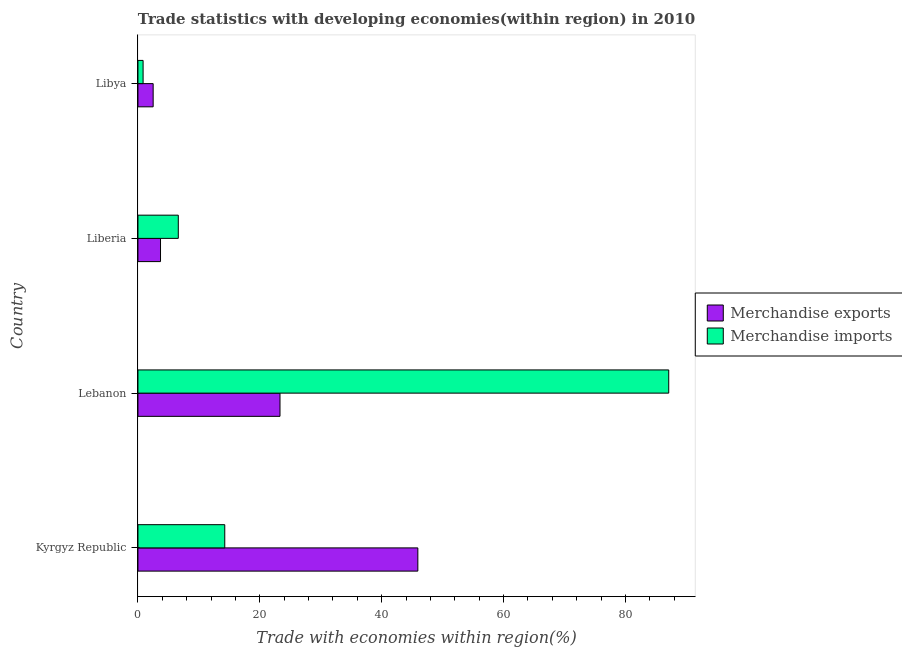How many different coloured bars are there?
Offer a very short reply. 2. How many groups of bars are there?
Your answer should be compact. 4. Are the number of bars per tick equal to the number of legend labels?
Offer a terse response. Yes. Are the number of bars on each tick of the Y-axis equal?
Your response must be concise. Yes. What is the label of the 2nd group of bars from the top?
Offer a terse response. Liberia. In how many cases, is the number of bars for a given country not equal to the number of legend labels?
Offer a terse response. 0. What is the merchandise imports in Kyrgyz Republic?
Offer a terse response. 14.25. Across all countries, what is the maximum merchandise exports?
Ensure brevity in your answer.  45.94. Across all countries, what is the minimum merchandise exports?
Give a very brief answer. 2.49. In which country was the merchandise imports maximum?
Your answer should be very brief. Lebanon. In which country was the merchandise imports minimum?
Give a very brief answer. Libya. What is the total merchandise imports in the graph?
Your answer should be compact. 108.83. What is the difference between the merchandise exports in Kyrgyz Republic and that in Liberia?
Ensure brevity in your answer.  42.23. What is the difference between the merchandise imports in Libya and the merchandise exports in Liberia?
Offer a very short reply. -2.86. What is the average merchandise imports per country?
Your answer should be very brief. 27.21. What is the difference between the merchandise imports and merchandise exports in Kyrgyz Republic?
Your answer should be compact. -31.69. In how many countries, is the merchandise exports greater than 20 %?
Your response must be concise. 2. What is the ratio of the merchandise imports in Kyrgyz Republic to that in Liberia?
Ensure brevity in your answer.  2.15. Is the difference between the merchandise imports in Liberia and Libya greater than the difference between the merchandise exports in Liberia and Libya?
Offer a terse response. Yes. What is the difference between the highest and the second highest merchandise imports?
Offer a terse response. 72.87. What is the difference between the highest and the lowest merchandise imports?
Make the answer very short. 86.27. In how many countries, is the merchandise imports greater than the average merchandise imports taken over all countries?
Keep it short and to the point. 1. Is the sum of the merchandise imports in Lebanon and Liberia greater than the maximum merchandise exports across all countries?
Your response must be concise. Yes. What does the 2nd bar from the top in Lebanon represents?
Ensure brevity in your answer.  Merchandise exports. What does the 2nd bar from the bottom in Liberia represents?
Provide a short and direct response. Merchandise imports. How many countries are there in the graph?
Ensure brevity in your answer.  4. Are the values on the major ticks of X-axis written in scientific E-notation?
Ensure brevity in your answer.  No. Does the graph contain any zero values?
Provide a succinct answer. No. Does the graph contain grids?
Keep it short and to the point. No. How many legend labels are there?
Provide a succinct answer. 2. How are the legend labels stacked?
Ensure brevity in your answer.  Vertical. What is the title of the graph?
Make the answer very short. Trade statistics with developing economies(within region) in 2010. Does "Savings" appear as one of the legend labels in the graph?
Ensure brevity in your answer.  No. What is the label or title of the X-axis?
Offer a terse response. Trade with economies within region(%). What is the label or title of the Y-axis?
Your response must be concise. Country. What is the Trade with economies within region(%) in Merchandise exports in Kyrgyz Republic?
Your answer should be very brief. 45.94. What is the Trade with economies within region(%) of Merchandise imports in Kyrgyz Republic?
Your answer should be very brief. 14.25. What is the Trade with economies within region(%) in Merchandise exports in Lebanon?
Give a very brief answer. 23.31. What is the Trade with economies within region(%) of Merchandise imports in Lebanon?
Your answer should be compact. 87.11. What is the Trade with economies within region(%) of Merchandise exports in Liberia?
Your answer should be compact. 3.7. What is the Trade with economies within region(%) of Merchandise imports in Liberia?
Give a very brief answer. 6.62. What is the Trade with economies within region(%) of Merchandise exports in Libya?
Ensure brevity in your answer.  2.49. What is the Trade with economies within region(%) in Merchandise imports in Libya?
Make the answer very short. 0.84. Across all countries, what is the maximum Trade with economies within region(%) of Merchandise exports?
Provide a short and direct response. 45.94. Across all countries, what is the maximum Trade with economies within region(%) in Merchandise imports?
Offer a terse response. 87.11. Across all countries, what is the minimum Trade with economies within region(%) in Merchandise exports?
Offer a very short reply. 2.49. Across all countries, what is the minimum Trade with economies within region(%) in Merchandise imports?
Offer a terse response. 0.84. What is the total Trade with economies within region(%) in Merchandise exports in the graph?
Offer a terse response. 75.45. What is the total Trade with economies within region(%) in Merchandise imports in the graph?
Offer a very short reply. 108.83. What is the difference between the Trade with economies within region(%) of Merchandise exports in Kyrgyz Republic and that in Lebanon?
Ensure brevity in your answer.  22.62. What is the difference between the Trade with economies within region(%) of Merchandise imports in Kyrgyz Republic and that in Lebanon?
Ensure brevity in your answer.  -72.87. What is the difference between the Trade with economies within region(%) in Merchandise exports in Kyrgyz Republic and that in Liberia?
Keep it short and to the point. 42.24. What is the difference between the Trade with economies within region(%) in Merchandise imports in Kyrgyz Republic and that in Liberia?
Give a very brief answer. 7.63. What is the difference between the Trade with economies within region(%) of Merchandise exports in Kyrgyz Republic and that in Libya?
Ensure brevity in your answer.  43.44. What is the difference between the Trade with economies within region(%) in Merchandise imports in Kyrgyz Republic and that in Libya?
Offer a very short reply. 13.41. What is the difference between the Trade with economies within region(%) in Merchandise exports in Lebanon and that in Liberia?
Your response must be concise. 19.61. What is the difference between the Trade with economies within region(%) in Merchandise imports in Lebanon and that in Liberia?
Offer a terse response. 80.49. What is the difference between the Trade with economies within region(%) of Merchandise exports in Lebanon and that in Libya?
Your answer should be compact. 20.82. What is the difference between the Trade with economies within region(%) in Merchandise imports in Lebanon and that in Libya?
Make the answer very short. 86.27. What is the difference between the Trade with economies within region(%) in Merchandise exports in Liberia and that in Libya?
Provide a short and direct response. 1.21. What is the difference between the Trade with economies within region(%) of Merchandise imports in Liberia and that in Libya?
Provide a succinct answer. 5.78. What is the difference between the Trade with economies within region(%) in Merchandise exports in Kyrgyz Republic and the Trade with economies within region(%) in Merchandise imports in Lebanon?
Provide a short and direct response. -41.18. What is the difference between the Trade with economies within region(%) in Merchandise exports in Kyrgyz Republic and the Trade with economies within region(%) in Merchandise imports in Liberia?
Keep it short and to the point. 39.32. What is the difference between the Trade with economies within region(%) in Merchandise exports in Kyrgyz Republic and the Trade with economies within region(%) in Merchandise imports in Libya?
Give a very brief answer. 45.09. What is the difference between the Trade with economies within region(%) of Merchandise exports in Lebanon and the Trade with economies within region(%) of Merchandise imports in Liberia?
Make the answer very short. 16.69. What is the difference between the Trade with economies within region(%) of Merchandise exports in Lebanon and the Trade with economies within region(%) of Merchandise imports in Libya?
Your response must be concise. 22.47. What is the difference between the Trade with economies within region(%) of Merchandise exports in Liberia and the Trade with economies within region(%) of Merchandise imports in Libya?
Your answer should be very brief. 2.86. What is the average Trade with economies within region(%) of Merchandise exports per country?
Your answer should be very brief. 18.86. What is the average Trade with economies within region(%) in Merchandise imports per country?
Make the answer very short. 27.21. What is the difference between the Trade with economies within region(%) of Merchandise exports and Trade with economies within region(%) of Merchandise imports in Kyrgyz Republic?
Ensure brevity in your answer.  31.69. What is the difference between the Trade with economies within region(%) of Merchandise exports and Trade with economies within region(%) of Merchandise imports in Lebanon?
Ensure brevity in your answer.  -63.8. What is the difference between the Trade with economies within region(%) of Merchandise exports and Trade with economies within region(%) of Merchandise imports in Liberia?
Give a very brief answer. -2.92. What is the difference between the Trade with economies within region(%) in Merchandise exports and Trade with economies within region(%) in Merchandise imports in Libya?
Ensure brevity in your answer.  1.65. What is the ratio of the Trade with economies within region(%) in Merchandise exports in Kyrgyz Republic to that in Lebanon?
Your response must be concise. 1.97. What is the ratio of the Trade with economies within region(%) in Merchandise imports in Kyrgyz Republic to that in Lebanon?
Make the answer very short. 0.16. What is the ratio of the Trade with economies within region(%) of Merchandise exports in Kyrgyz Republic to that in Liberia?
Provide a short and direct response. 12.41. What is the ratio of the Trade with economies within region(%) of Merchandise imports in Kyrgyz Republic to that in Liberia?
Give a very brief answer. 2.15. What is the ratio of the Trade with economies within region(%) in Merchandise exports in Kyrgyz Republic to that in Libya?
Give a very brief answer. 18.42. What is the ratio of the Trade with economies within region(%) in Merchandise imports in Kyrgyz Republic to that in Libya?
Offer a very short reply. 16.9. What is the ratio of the Trade with economies within region(%) of Merchandise exports in Lebanon to that in Liberia?
Your answer should be compact. 6.3. What is the ratio of the Trade with economies within region(%) of Merchandise imports in Lebanon to that in Liberia?
Provide a succinct answer. 13.16. What is the ratio of the Trade with economies within region(%) of Merchandise exports in Lebanon to that in Libya?
Ensure brevity in your answer.  9.35. What is the ratio of the Trade with economies within region(%) of Merchandise imports in Lebanon to that in Libya?
Give a very brief answer. 103.34. What is the ratio of the Trade with economies within region(%) of Merchandise exports in Liberia to that in Libya?
Offer a very short reply. 1.49. What is the ratio of the Trade with economies within region(%) in Merchandise imports in Liberia to that in Libya?
Your response must be concise. 7.85. What is the difference between the highest and the second highest Trade with economies within region(%) of Merchandise exports?
Your response must be concise. 22.62. What is the difference between the highest and the second highest Trade with economies within region(%) of Merchandise imports?
Your response must be concise. 72.87. What is the difference between the highest and the lowest Trade with economies within region(%) of Merchandise exports?
Keep it short and to the point. 43.44. What is the difference between the highest and the lowest Trade with economies within region(%) of Merchandise imports?
Your answer should be very brief. 86.27. 